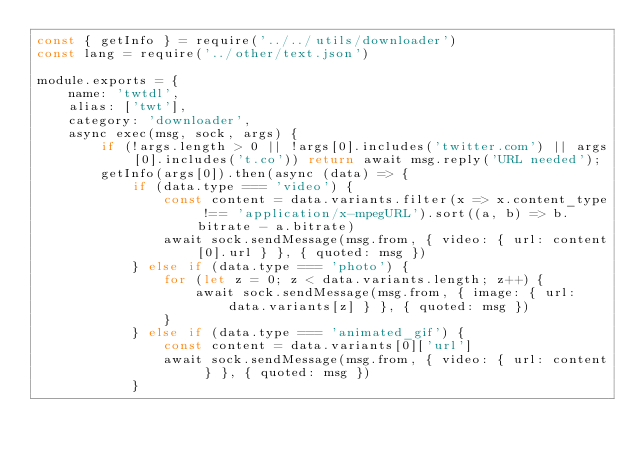<code> <loc_0><loc_0><loc_500><loc_500><_JavaScript_>const { getInfo } = require('../../utils/downloader')
const lang = require('../other/text.json')

module.exports = {
    name: 'twtdl',
    alias: ['twt'],
    category: 'downloader',
    async exec(msg, sock, args) {
        if (!args.length > 0 || !args[0].includes('twitter.com') || args[0].includes('t.co')) return await msg.reply('URL needed');
        getInfo(args[0]).then(async (data) => {
            if (data.type === 'video') {
                const content = data.variants.filter(x => x.content_type !== 'application/x-mpegURL').sort((a, b) => b.bitrate - a.bitrate)
                await sock.sendMessage(msg.from, { video: { url: content[0].url } }, { quoted: msg })
            } else if (data.type === 'photo') {
                for (let z = 0; z < data.variants.length; z++) {
                    await sock.sendMessage(msg.from, { image: { url: data.variants[z] } }, { quoted: msg })
                }
            } else if (data.type === 'animated_gif') {
                const content = data.variants[0]['url']
                await sock.sendMessage(msg.from, { video: { url: content } }, { quoted: msg })
            }</code> 